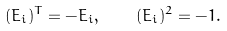<formula> <loc_0><loc_0><loc_500><loc_500>( E _ { i } ) ^ { T } = - E _ { i } , \quad ( E _ { i } ) ^ { 2 } = - 1 .</formula> 